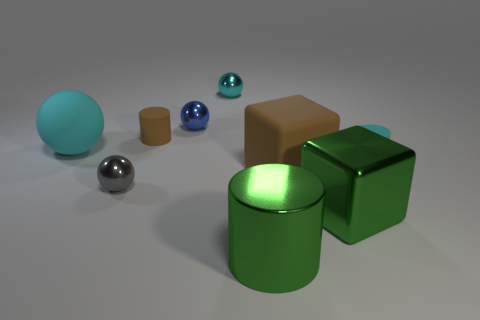Add 1 large brown rubber balls. How many objects exist? 10 Subtract all cylinders. How many objects are left? 6 Subtract all blue spheres. Subtract all small balls. How many objects are left? 5 Add 2 small cyan spheres. How many small cyan spheres are left? 3 Add 3 large metallic things. How many large metallic things exist? 5 Subtract 0 gray cylinders. How many objects are left? 9 